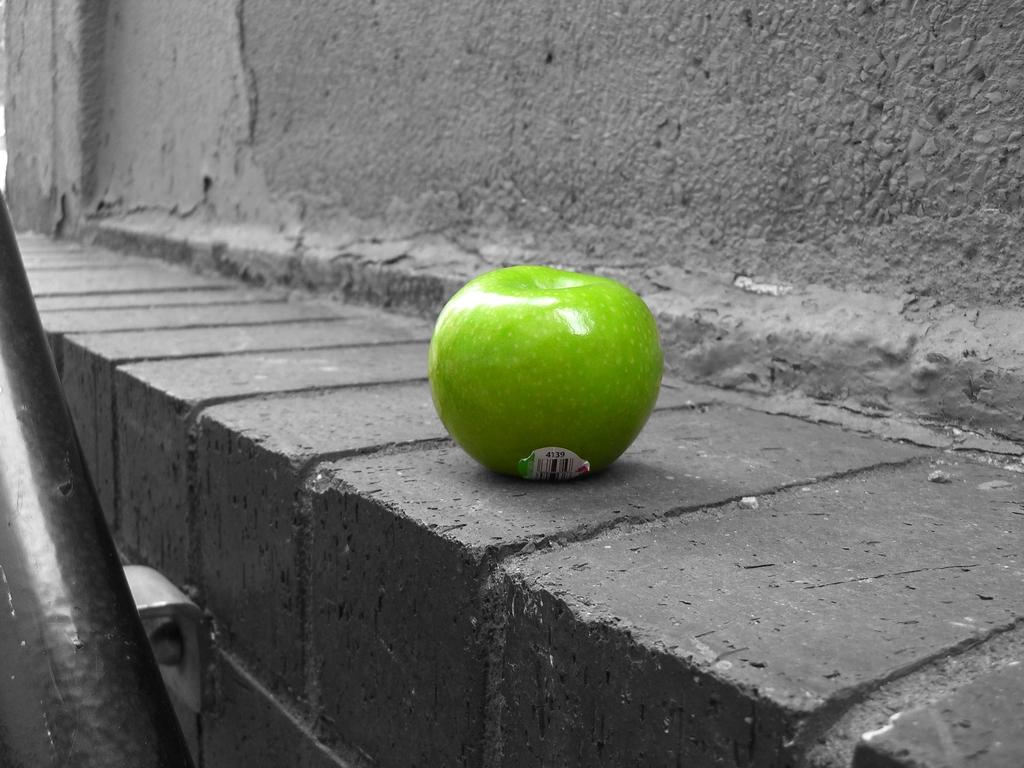What type of fruit is in the image? There is a green apple in the image. Where is the green apple located? The green apple is on a small wall. Is there anything attached to the apple? Yes, there is a sticker attached to the apple. What can be seen in the background of the image? There is a wall in the background of the image. What are the two objects on the bottom left side of the image? Unfortunately, the provided facts do not mention the two objects on the bottom left side of the image. What is the income of the person who owns the green apple in the image? There is no information about the income of the person who owns the green apple in the image. What scent can be detected from the green apple in the image? The provided facts do not mention any scent associated with the green apple in the image. 